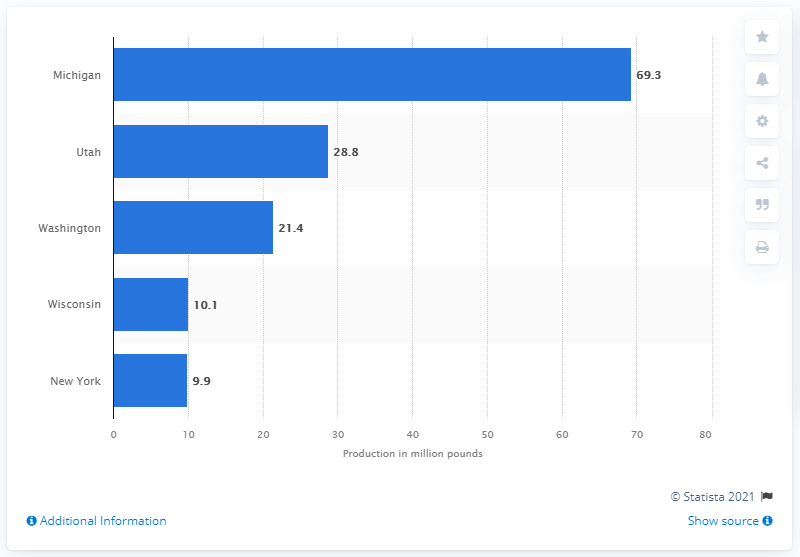Mention a couple of crucial points in this snapshot. In 2020, the production of tart cherries in Michigan totaled approximately 69.3 million pounds. Michigan produced 69.3 million pounds of tart cherries in 2020. 